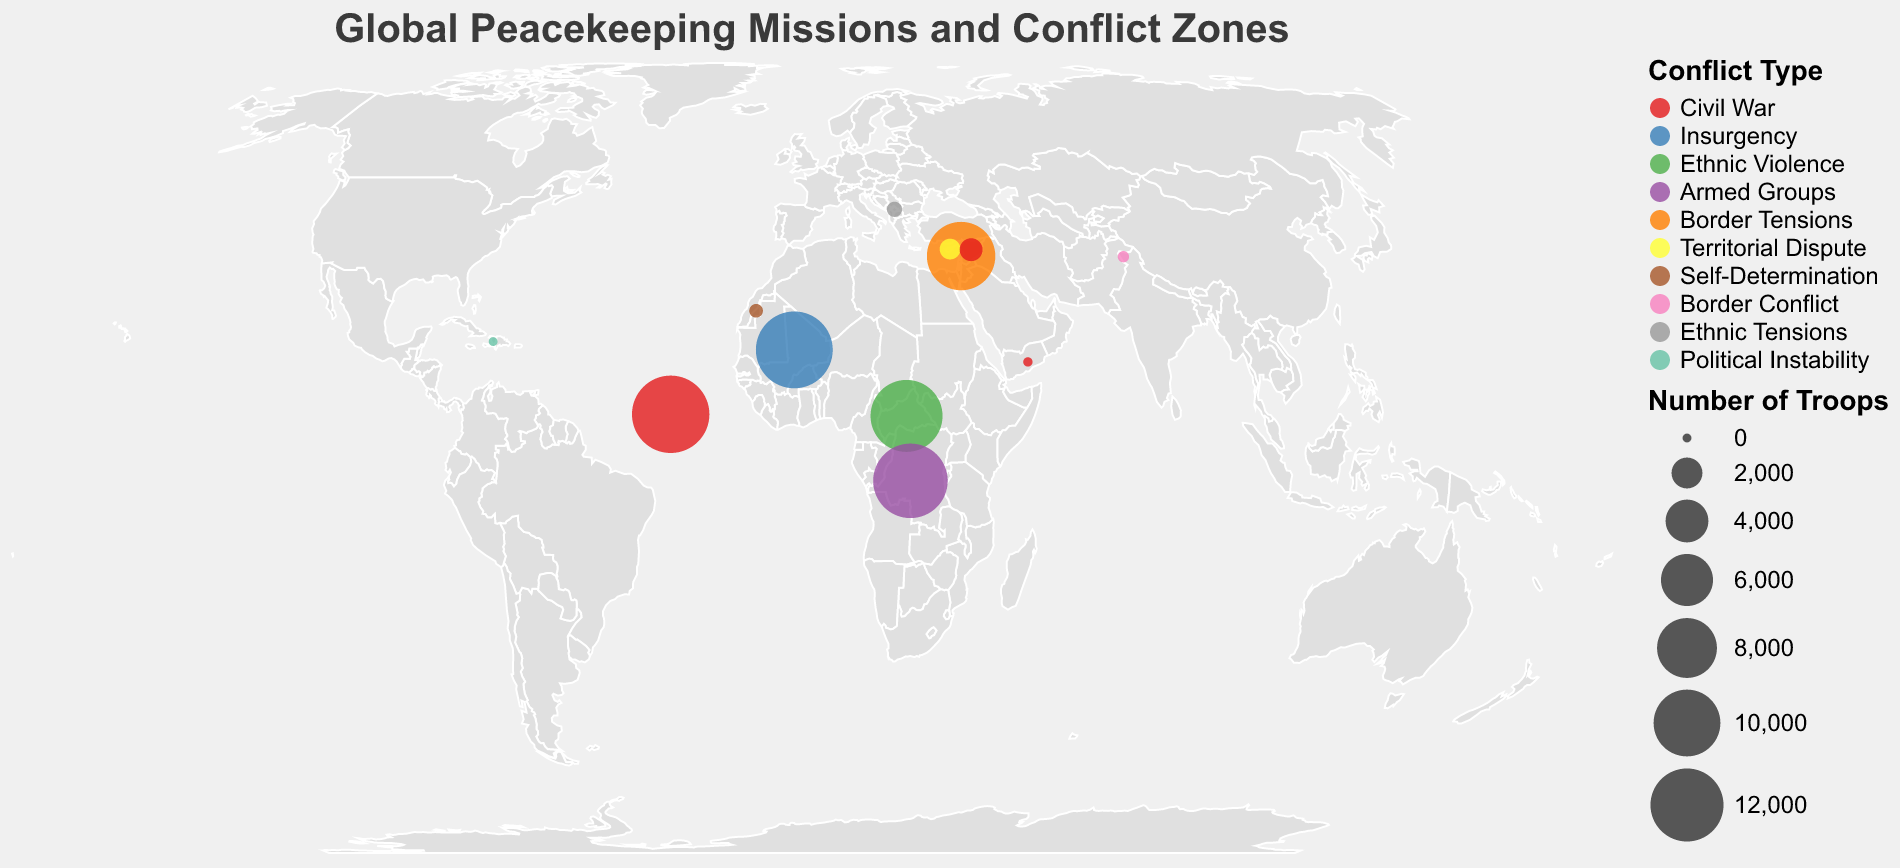What's the largest deployed peacekeeping mission by troops? By looking at the sizes of the circles, the largest circle which represents the number of troops is in South Sudan, associated with the UNMISS mission. Hence, UNMISS in South Sudan has the highest number of troops at 13,500.
Answer: 13,500 Which conflict type is found in both Lebanon and Syria? Observing the legend and the color of the circles for Lebanon and Syria, both countries have different conflict types. Lebanon has 'Border Tensions' while Syria has 'Civil War', meaning there is no same conflict type for these two countries.
Answer: None What is the total number of troops deployed in Civil War conflict zones? Summing the troops in civil war conflict zones: South Sudan (13,500), Syria (1,024), and Yemen (18). Therefore, the total is 13,500 + 1,024 + 18 = 14,542.
Answer: 14,542 How many missions have troop deployments of fewer than 1,000 personnel? Referring to the sizes of the circles, we find the missions in Cyprus, Western Sahara, India-Pakistan Border, Kosovo, Haiti, and Yemen. Counting these results in a total of 6 missions.
Answer: 6 Which conflict type is represented by the smallest number of troops and how many troops is that? Looking at the circles’ sizes and their respective conflict types, Yemen has the smallest circle with 'Civil War' and a troop deployment of 18 as indicated in the tooltip.
Answer: 18 Which region has the highest density of peacekeeping missions? Observing the geographic distribution, the region around Central Africa (including countries such as South Sudan, Mali, Central African Republic, and Democratic Republic of Congo) has the highest concentration of peacekeeping missions.
Answer: Central Africa How many countries listed are dealing with ethnic violence or ethnic tensions? Referring to the conflict type and counting, Central African Republic (Ethnic Violence) and Kosovo (Ethnic Tensions) amount to a total of 2 countries.
Answer: 2 Between Mali and Central African Republic, which country has more troops deployed? Comparing the sizes of the circles and the troop counts for each country, Mali (13,289) has more troops deployed than Central African Republic (11,650).
Answer: Mali 